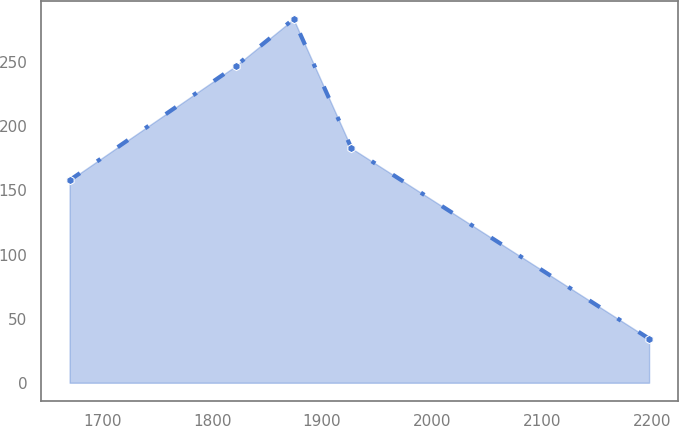Convert chart to OTSL. <chart><loc_0><loc_0><loc_500><loc_500><line_chart><ecel><fcel>Unnamed: 1<nl><fcel>1670.35<fcel>157.93<nl><fcel>1821.36<fcel>246.97<nl><fcel>1874.09<fcel>283.6<nl><fcel>1926.82<fcel>182.85<nl><fcel>2197.63<fcel>34.38<nl></chart> 